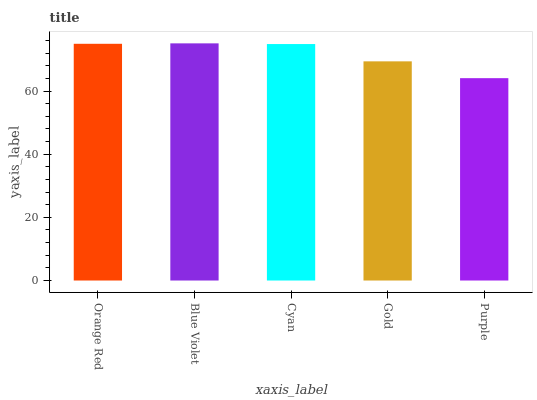Is Purple the minimum?
Answer yes or no. Yes. Is Blue Violet the maximum?
Answer yes or no. Yes. Is Cyan the minimum?
Answer yes or no. No. Is Cyan the maximum?
Answer yes or no. No. Is Blue Violet greater than Cyan?
Answer yes or no. Yes. Is Cyan less than Blue Violet?
Answer yes or no. Yes. Is Cyan greater than Blue Violet?
Answer yes or no. No. Is Blue Violet less than Cyan?
Answer yes or no. No. Is Cyan the high median?
Answer yes or no. Yes. Is Cyan the low median?
Answer yes or no. Yes. Is Orange Red the high median?
Answer yes or no. No. Is Gold the low median?
Answer yes or no. No. 